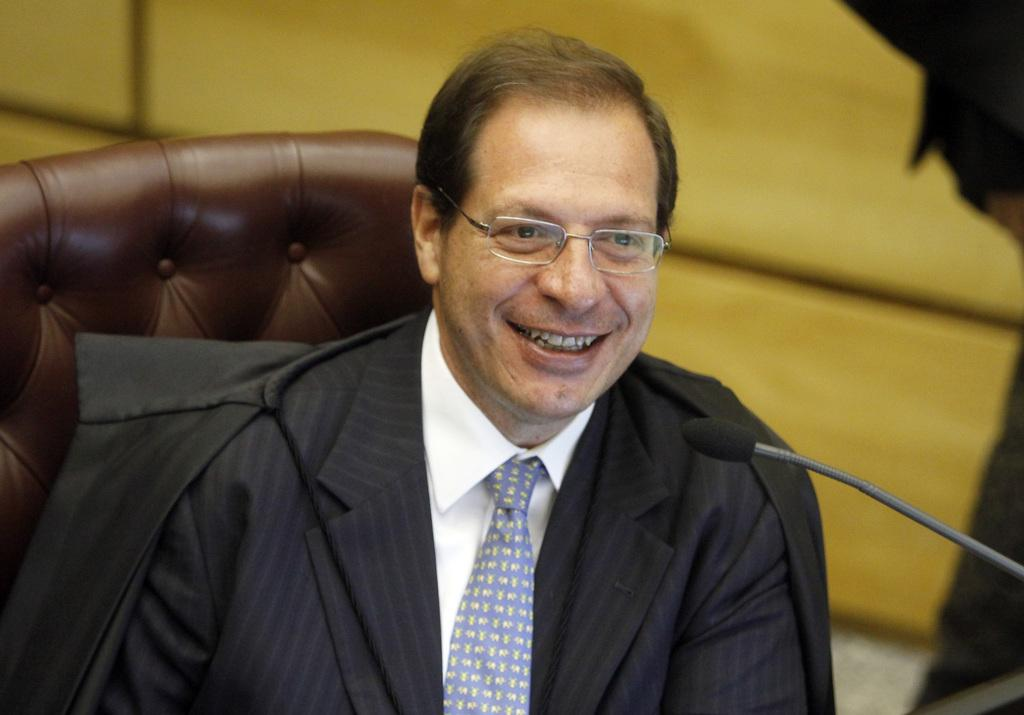What is the person in the image doing? The person is sitting in the image. What is the person's facial expression? The person is smiling. What object can be seen near the person? There is a microphone (mic) in the image. What is visible in the background of the image? There is a wall in the background of the image. What type of creature is crawling on the wall in the image? There is no creature visible on the wall in the image. What is the plot of the story being told through the image? The image does not depict a story or plot; it simply shows a person sitting with a microphone. 